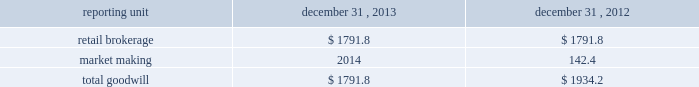Individual loan before being modified as a tdr in the discounted cash flow analysis in order to determine that specific loan 2019s expected impairment .
Specifically , a loan that has a more severe delinquency history prior to modification will have a higher future default rate in the discounted cash flow analysis than a loan that was not as severely delinquent .
For both of the one- to four-family and home equity loan portfolio segments , the pre- modification delinquency status , the borrower 2019s current credit score and other credit bureau attributes , in addition to each loan 2019s individual default experience and credit characteristics , are incorporated into the calculation of the specific allowance .
A specific allowance is established to the extent that the recorded investment exceeds the discounted cash flows of a tdr with a corresponding charge to provision for loan losses .
The specific allowance for these individually impaired loans represents the forecasted losses over the estimated remaining life of the loan , including the economic concession to the borrower .
Effects if actual results differ historic volatility in the credit markets has substantially increased the complexity and uncertainty involved in estimating the losses inherent in the loan portfolio .
In the current market it is difficult to estimate how potential changes in the quantitative and qualitative factors , including the impact of home equity lines of credit converting from interest only to amortizing loans or requiring borrowers to repay the loan in full at the end of the draw period , might impact the allowance for loan losses .
If our underlying assumptions and judgments prove to be inaccurate , the allowance for loan losses could be insufficient to cover actual losses .
We may be required under such circumstances to further increase the provision for loan losses , which could have an adverse effect on the regulatory capital position and results of operations in future periods .
During the normal course of conducting examinations , our banking regulators , the occ and federal reserve , continue to review our business and practices .
This process is dynamic and ongoing and we cannot be certain that additional changes or actions will not result from their continuing review .
Valuation of goodwill and other intangible assets description goodwill and other intangible assets are evaluated for impairment on an annual basis as of november 30 and in interim periods when events or changes indicate the carrying value may not be recoverable , such as a significant deterioration in the operating environment or a decision to sell or dispose of a reporting unit .
Goodwill and other intangible assets net of amortization were $ 1.8 billion and $ 0.2 billion , respectively , at december 31 , 2013 .
Judgments goodwill is allocated to reporting units , which are components of the business that are one level below operating segments .
Reporting units are evaluated for impairment individually during the annual assessment .
Estimating the fair value of reporting units and the assets , liabilities and intangible assets of a reporting unit is a subjective process that involves the use of estimates and judgments , particularly related to cash flows , the appropriate discount rates and an applicable control premium .
Management judgment is required to assess whether the carrying value of the reporting unit can be supported by the fair value of the individual reporting unit .
There are various valuation methodologies , such as the market approach or discounted cash flow methods , that may be used to estimate the fair value of reporting units .
In applying these methodologies , we utilize a number of factors , including actual operating results , future business plans , economic projections , and market data .
The table shows the comparative data for the amount of goodwill allocated to our reporting units ( dollars in millions ) : .

As of december 31 , 2013 what was the ratio of the goodwill to the other intangible assets net of amortization? 
Rationale: as of december 31 , 2013 there was 9 times of goodwill to the other intangible assets net of amortization
Computations: (1.8 / 0.2)
Answer: 9.0. 